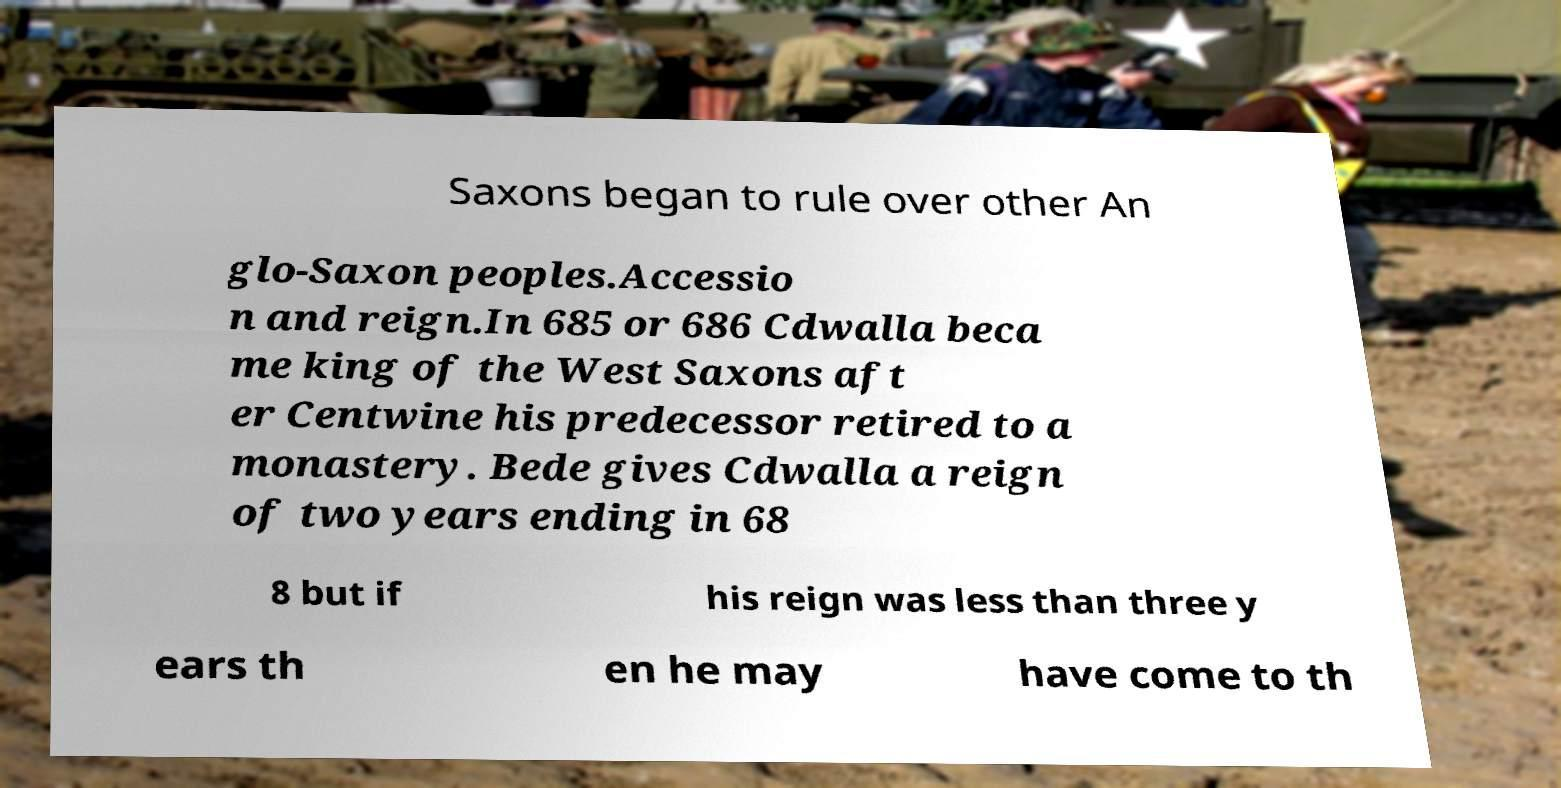Please read and relay the text visible in this image. What does it say? Saxons began to rule over other An glo-Saxon peoples.Accessio n and reign.In 685 or 686 Cdwalla beca me king of the West Saxons aft er Centwine his predecessor retired to a monastery. Bede gives Cdwalla a reign of two years ending in 68 8 but if his reign was less than three y ears th en he may have come to th 